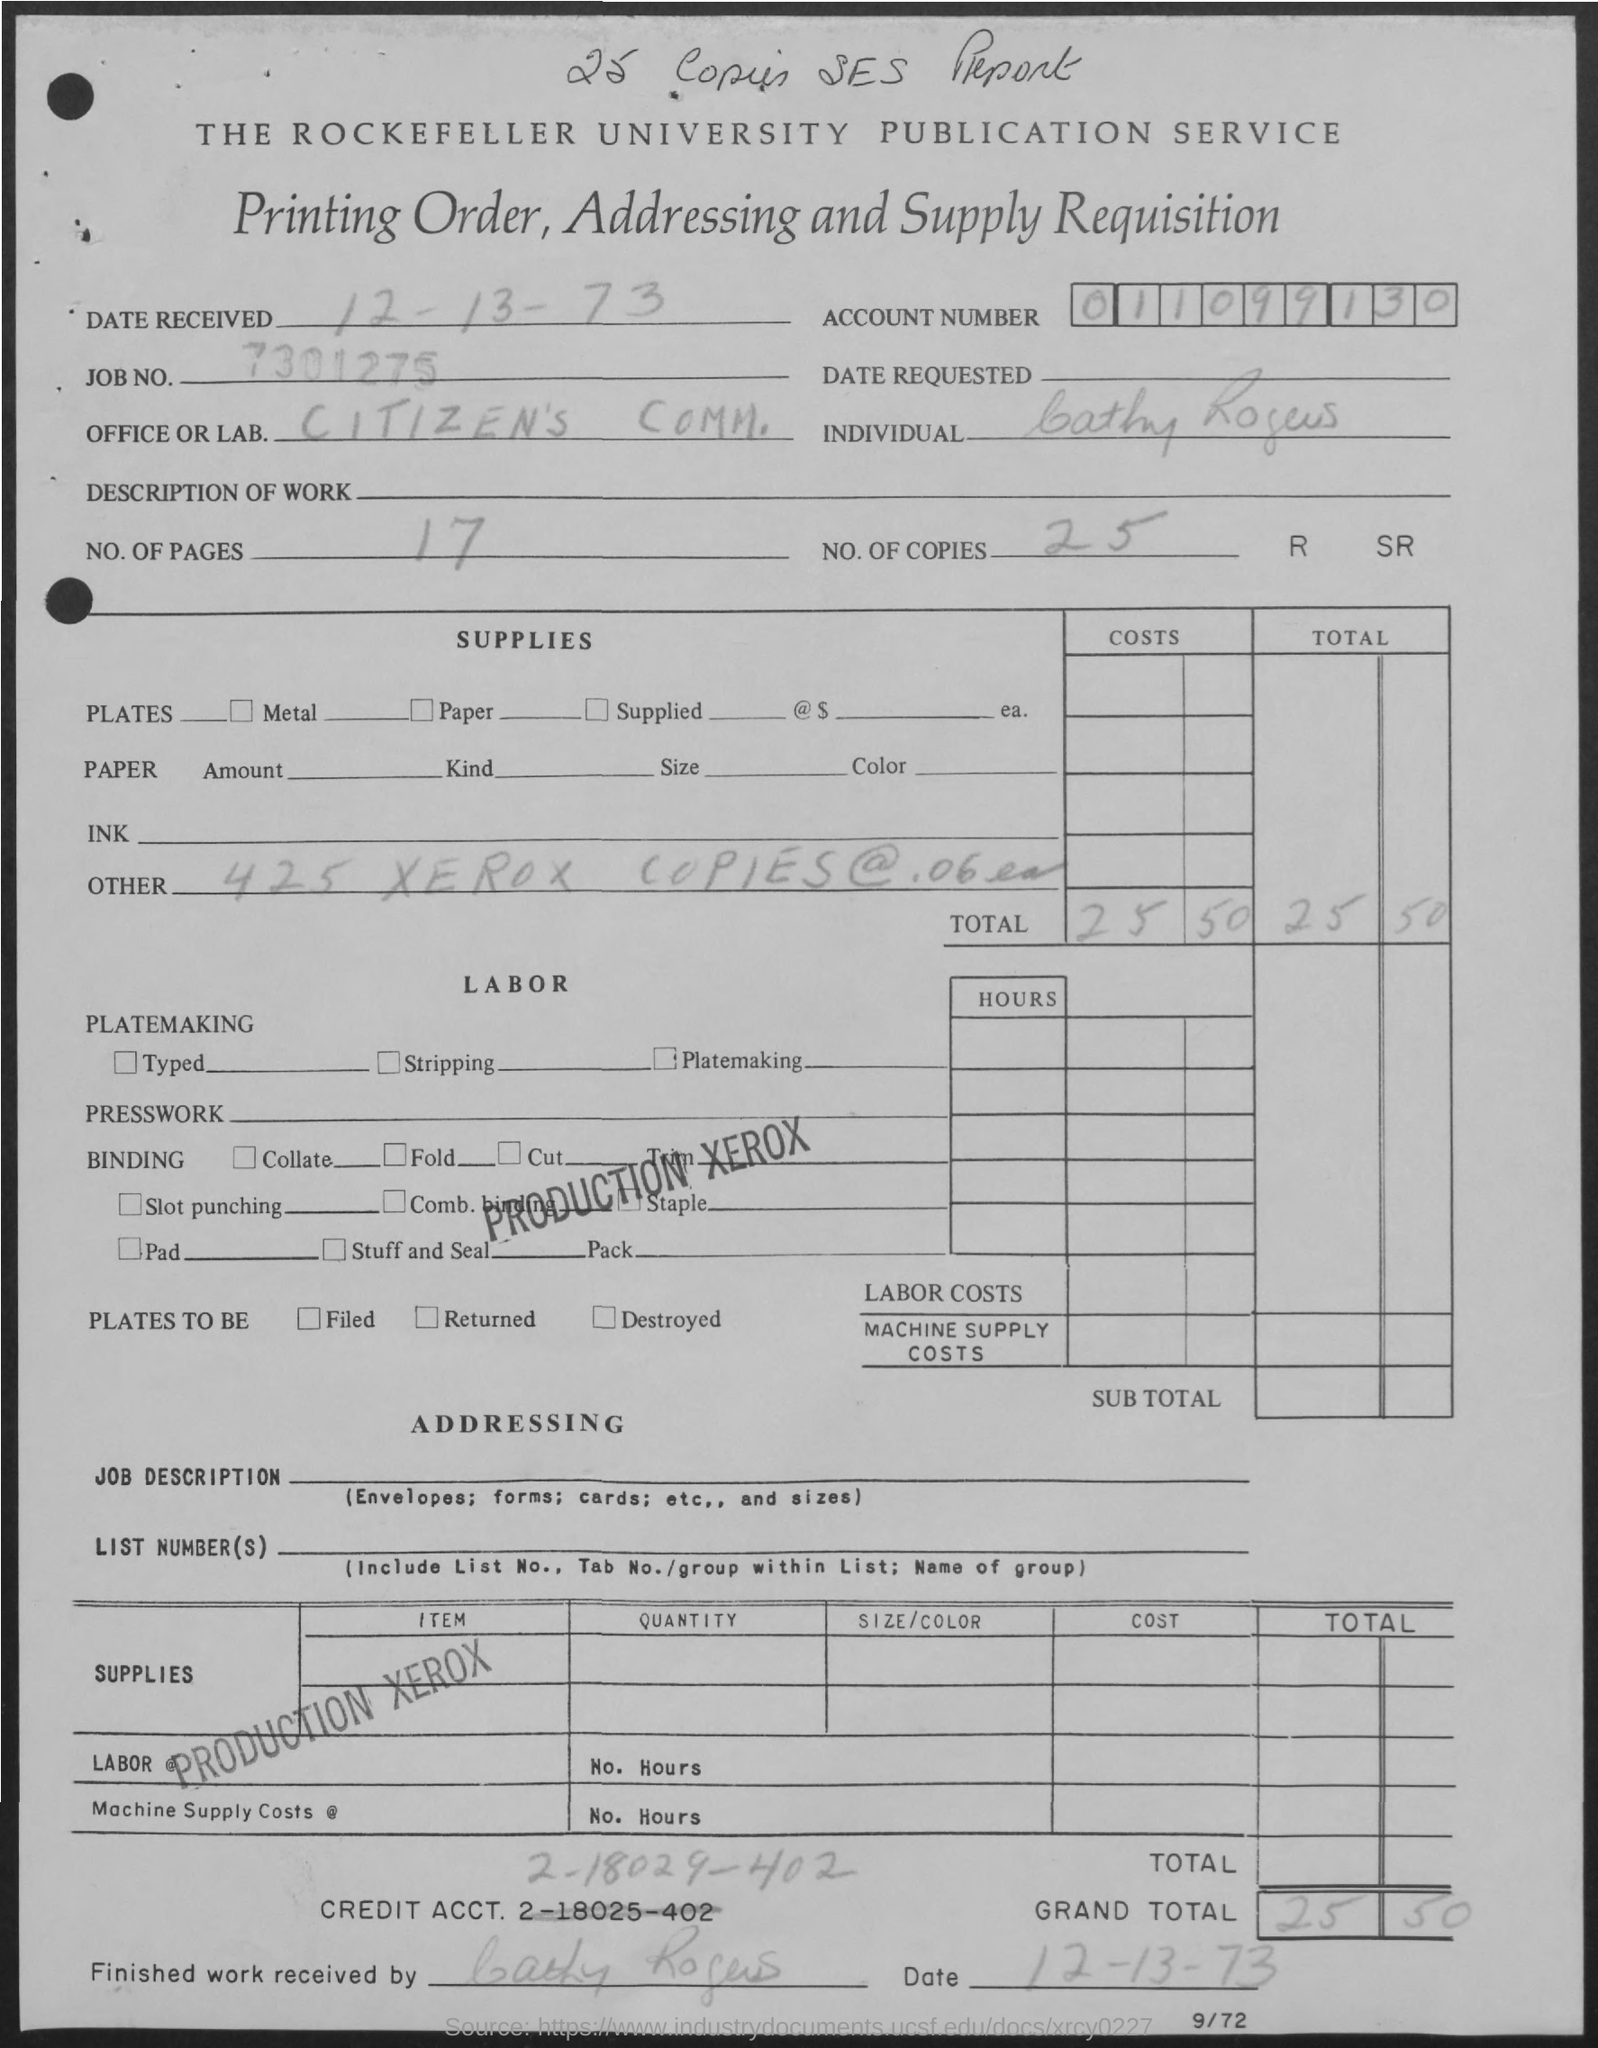Mention a couple of crucial points in this snapshot. The job number is 7301275... The Rockefeller University Publication service is mentioned at the top of the page. The account number is "011099130... The mentioned office/lab is the citizen's Community Office/Lab. There are 17 pages in total. 